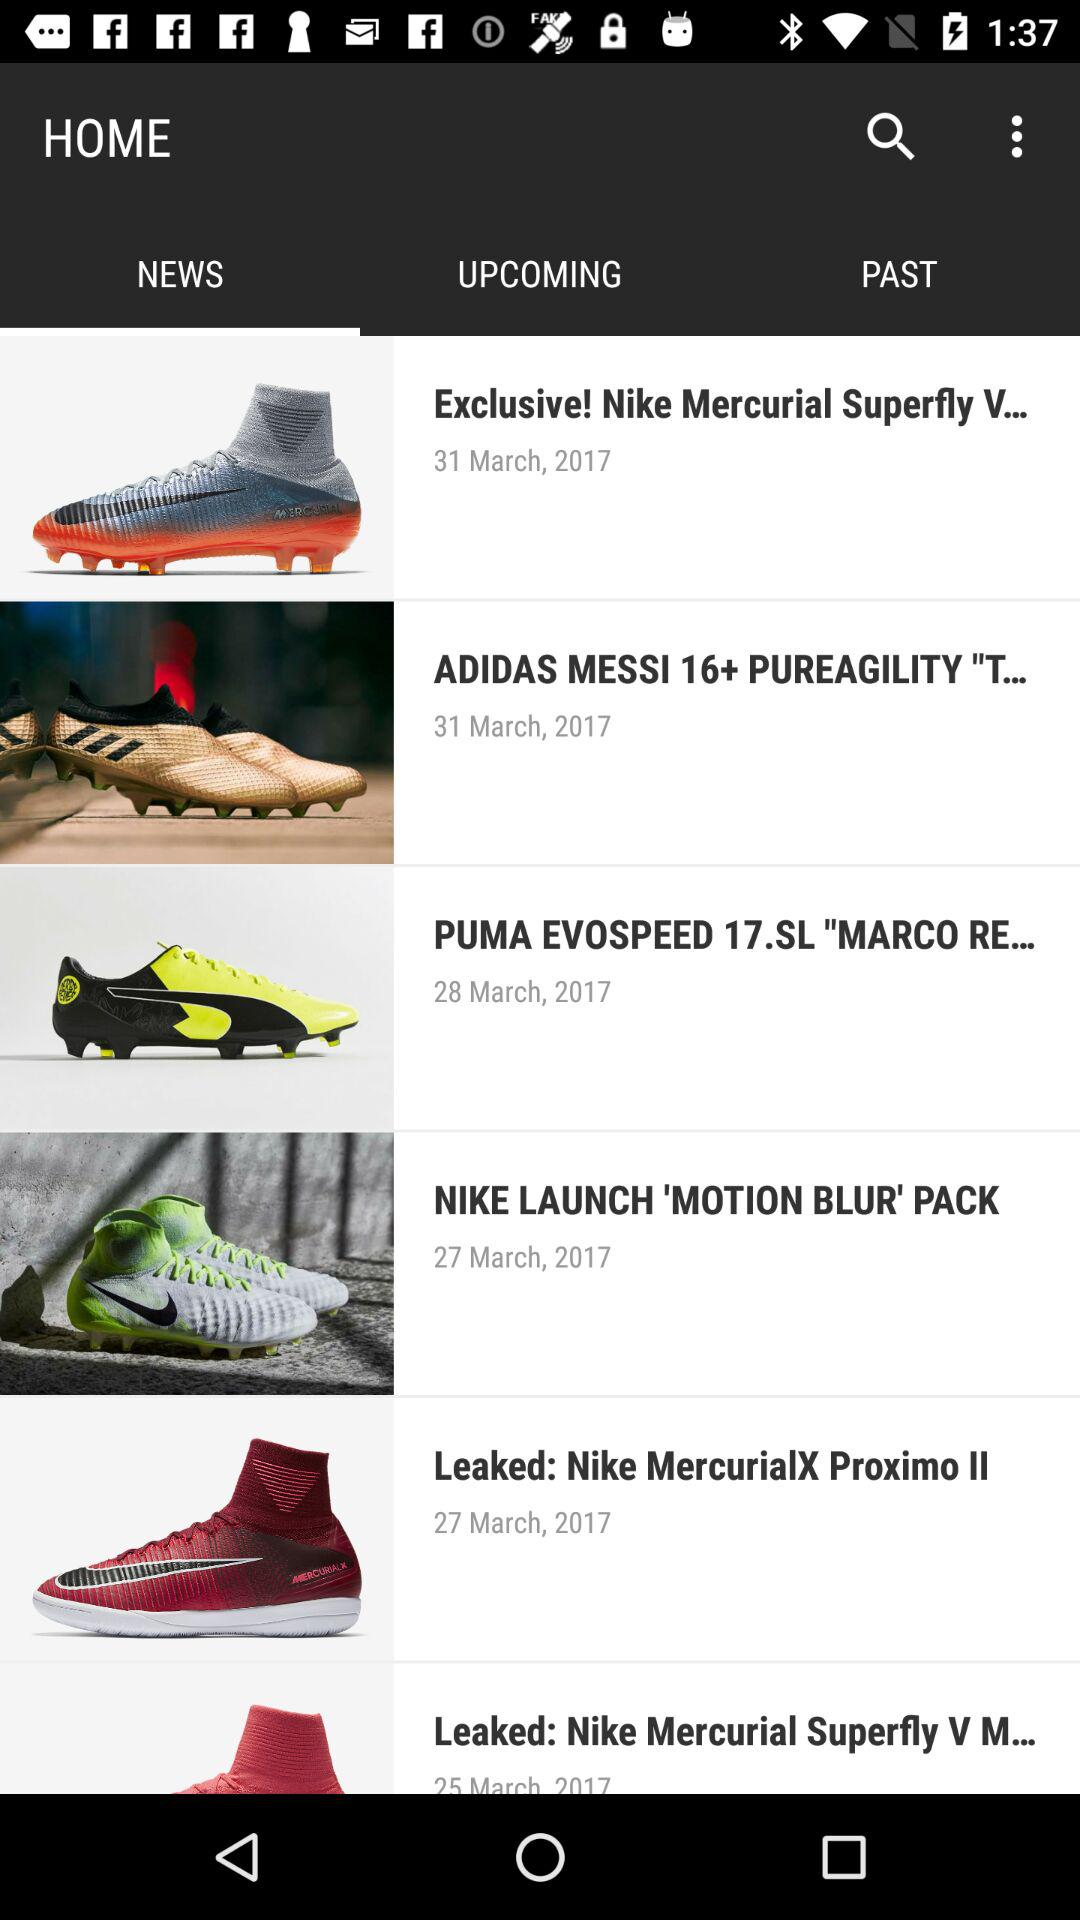On which date was "Leaked: Nike MercurialX Proximo II" posted? "Leaked: Nike MercurialX Proximo II" was posted on March 27, 2017. 